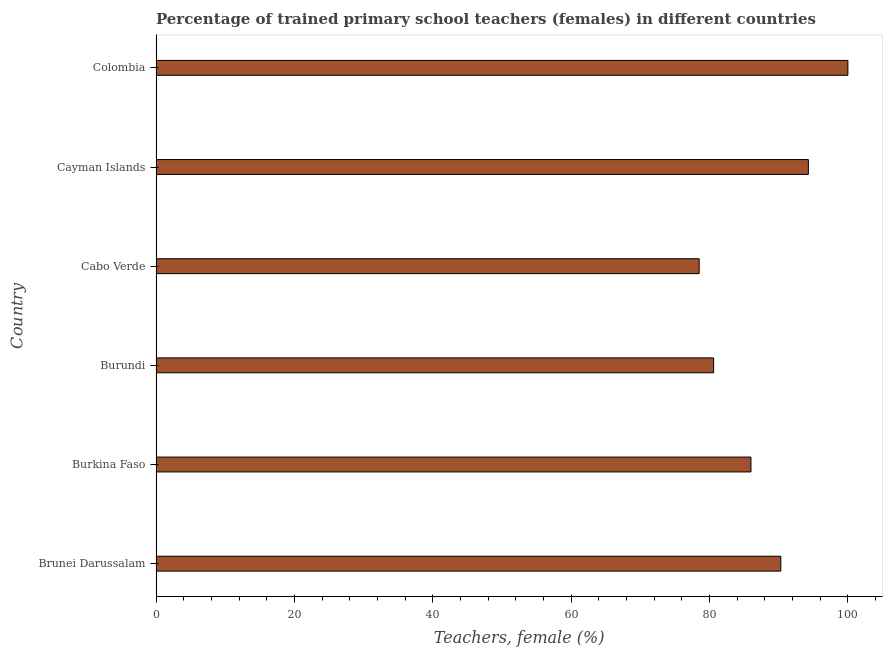Does the graph contain any zero values?
Give a very brief answer. No. What is the title of the graph?
Offer a terse response. Percentage of trained primary school teachers (females) in different countries. What is the label or title of the X-axis?
Offer a very short reply. Teachers, female (%). What is the label or title of the Y-axis?
Ensure brevity in your answer.  Country. What is the percentage of trained female teachers in Cabo Verde?
Offer a terse response. 78.5. Across all countries, what is the minimum percentage of trained female teachers?
Ensure brevity in your answer.  78.5. In which country was the percentage of trained female teachers minimum?
Your answer should be compact. Cabo Verde. What is the sum of the percentage of trained female teachers?
Give a very brief answer. 529.68. What is the difference between the percentage of trained female teachers in Brunei Darussalam and Cabo Verde?
Give a very brief answer. 11.8. What is the average percentage of trained female teachers per country?
Your response must be concise. 88.28. What is the median percentage of trained female teachers?
Your response must be concise. 88.15. In how many countries, is the percentage of trained female teachers greater than 8 %?
Your response must be concise. 6. What is the ratio of the percentage of trained female teachers in Brunei Darussalam to that in Cabo Verde?
Provide a succinct answer. 1.15. Is the difference between the percentage of trained female teachers in Brunei Darussalam and Burundi greater than the difference between any two countries?
Your response must be concise. No. What is the difference between the highest and the second highest percentage of trained female teachers?
Offer a terse response. 5.71. In how many countries, is the percentage of trained female teachers greater than the average percentage of trained female teachers taken over all countries?
Provide a short and direct response. 3. Are all the bars in the graph horizontal?
Provide a short and direct response. Yes. How many countries are there in the graph?
Keep it short and to the point. 6. Are the values on the major ticks of X-axis written in scientific E-notation?
Provide a succinct answer. No. What is the Teachers, female (%) of Brunei Darussalam?
Offer a very short reply. 90.31. What is the Teachers, female (%) in Burkina Faso?
Ensure brevity in your answer.  85.99. What is the Teachers, female (%) in Burundi?
Keep it short and to the point. 80.59. What is the Teachers, female (%) of Cabo Verde?
Your answer should be compact. 78.5. What is the Teachers, female (%) of Cayman Islands?
Offer a terse response. 94.29. What is the difference between the Teachers, female (%) in Brunei Darussalam and Burkina Faso?
Keep it short and to the point. 4.32. What is the difference between the Teachers, female (%) in Brunei Darussalam and Burundi?
Give a very brief answer. 9.71. What is the difference between the Teachers, female (%) in Brunei Darussalam and Cabo Verde?
Your response must be concise. 11.8. What is the difference between the Teachers, female (%) in Brunei Darussalam and Cayman Islands?
Keep it short and to the point. -3.98. What is the difference between the Teachers, female (%) in Brunei Darussalam and Colombia?
Give a very brief answer. -9.69. What is the difference between the Teachers, female (%) in Burkina Faso and Burundi?
Keep it short and to the point. 5.39. What is the difference between the Teachers, female (%) in Burkina Faso and Cabo Verde?
Offer a very short reply. 7.48. What is the difference between the Teachers, female (%) in Burkina Faso and Cayman Islands?
Your response must be concise. -8.3. What is the difference between the Teachers, female (%) in Burkina Faso and Colombia?
Give a very brief answer. -14.01. What is the difference between the Teachers, female (%) in Burundi and Cabo Verde?
Your answer should be very brief. 2.09. What is the difference between the Teachers, female (%) in Burundi and Cayman Islands?
Give a very brief answer. -13.69. What is the difference between the Teachers, female (%) in Burundi and Colombia?
Provide a succinct answer. -19.41. What is the difference between the Teachers, female (%) in Cabo Verde and Cayman Islands?
Give a very brief answer. -15.78. What is the difference between the Teachers, female (%) in Cabo Verde and Colombia?
Keep it short and to the point. -21.5. What is the difference between the Teachers, female (%) in Cayman Islands and Colombia?
Keep it short and to the point. -5.71. What is the ratio of the Teachers, female (%) in Brunei Darussalam to that in Burkina Faso?
Provide a succinct answer. 1.05. What is the ratio of the Teachers, female (%) in Brunei Darussalam to that in Burundi?
Provide a short and direct response. 1.12. What is the ratio of the Teachers, female (%) in Brunei Darussalam to that in Cabo Verde?
Make the answer very short. 1.15. What is the ratio of the Teachers, female (%) in Brunei Darussalam to that in Cayman Islands?
Make the answer very short. 0.96. What is the ratio of the Teachers, female (%) in Brunei Darussalam to that in Colombia?
Your answer should be compact. 0.9. What is the ratio of the Teachers, female (%) in Burkina Faso to that in Burundi?
Keep it short and to the point. 1.07. What is the ratio of the Teachers, female (%) in Burkina Faso to that in Cabo Verde?
Your answer should be very brief. 1.09. What is the ratio of the Teachers, female (%) in Burkina Faso to that in Cayman Islands?
Provide a succinct answer. 0.91. What is the ratio of the Teachers, female (%) in Burkina Faso to that in Colombia?
Ensure brevity in your answer.  0.86. What is the ratio of the Teachers, female (%) in Burundi to that in Cabo Verde?
Your response must be concise. 1.03. What is the ratio of the Teachers, female (%) in Burundi to that in Cayman Islands?
Provide a short and direct response. 0.85. What is the ratio of the Teachers, female (%) in Burundi to that in Colombia?
Offer a terse response. 0.81. What is the ratio of the Teachers, female (%) in Cabo Verde to that in Cayman Islands?
Provide a short and direct response. 0.83. What is the ratio of the Teachers, female (%) in Cabo Verde to that in Colombia?
Your answer should be compact. 0.79. What is the ratio of the Teachers, female (%) in Cayman Islands to that in Colombia?
Ensure brevity in your answer.  0.94. 